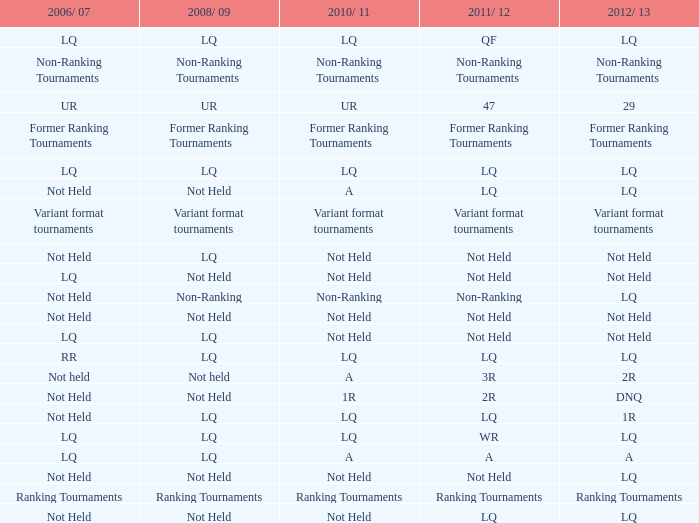What is 2006/07, when 2008/09 is LQ, and when 2010/11 is Not Held? LQ, Not Held. 